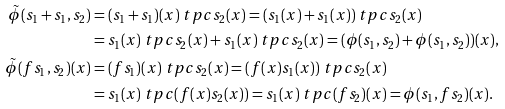<formula> <loc_0><loc_0><loc_500><loc_500>\tilde { \phi } ( s _ { 1 } + s _ { 1 } , s _ { 2 } ) & = ( s _ { 1 } + s _ { 1 } ) ( x ) \ t p c s _ { 2 } ( x ) = ( s _ { 1 } ( x ) + s _ { 1 } ( x ) ) \ t p c s _ { 2 } ( x ) \\ & = s _ { 1 } ( x ) \ t p c s _ { 2 } ( x ) + s _ { 1 } ( x ) \ t p c s _ { 2 } ( x ) = ( \phi ( s _ { 1 } , s _ { 2 } ) + \phi ( s _ { 1 } , s _ { 2 } ) ) ( x ) , \\ \tilde { \phi } ( f s _ { 1 } , s _ { 2 } ) ( x ) & = ( f s _ { 1 } ) ( x ) \ t p c s _ { 2 } ( x ) = ( f ( x ) s _ { 1 } ( x ) ) \ t p c s _ { 2 } ( x ) \\ & = s _ { 1 } ( x ) \ t p c ( f ( x ) s _ { 2 } ( x ) ) = s _ { 1 } ( x ) \ t p c ( f s _ { 2 } ) ( x ) = \phi ( s _ { 1 } , f s _ { 2 } ) ( x ) .</formula> 